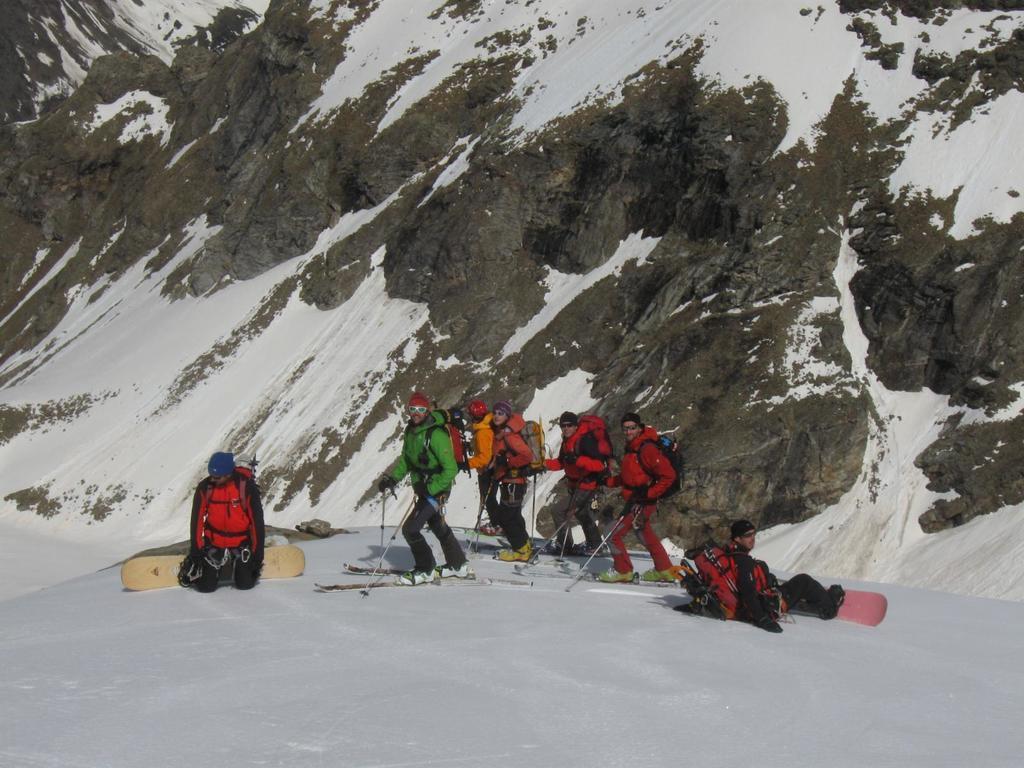In one or two sentences, can you explain what this image depicts? In this picture I can observe some people standing on the snow. They are on the skiing boards. All of them are holding skiing sticks in their hands. They are wearing hoodies and caps on their heads. In the background I can observe a mountain. There is some snow on the mountain. 